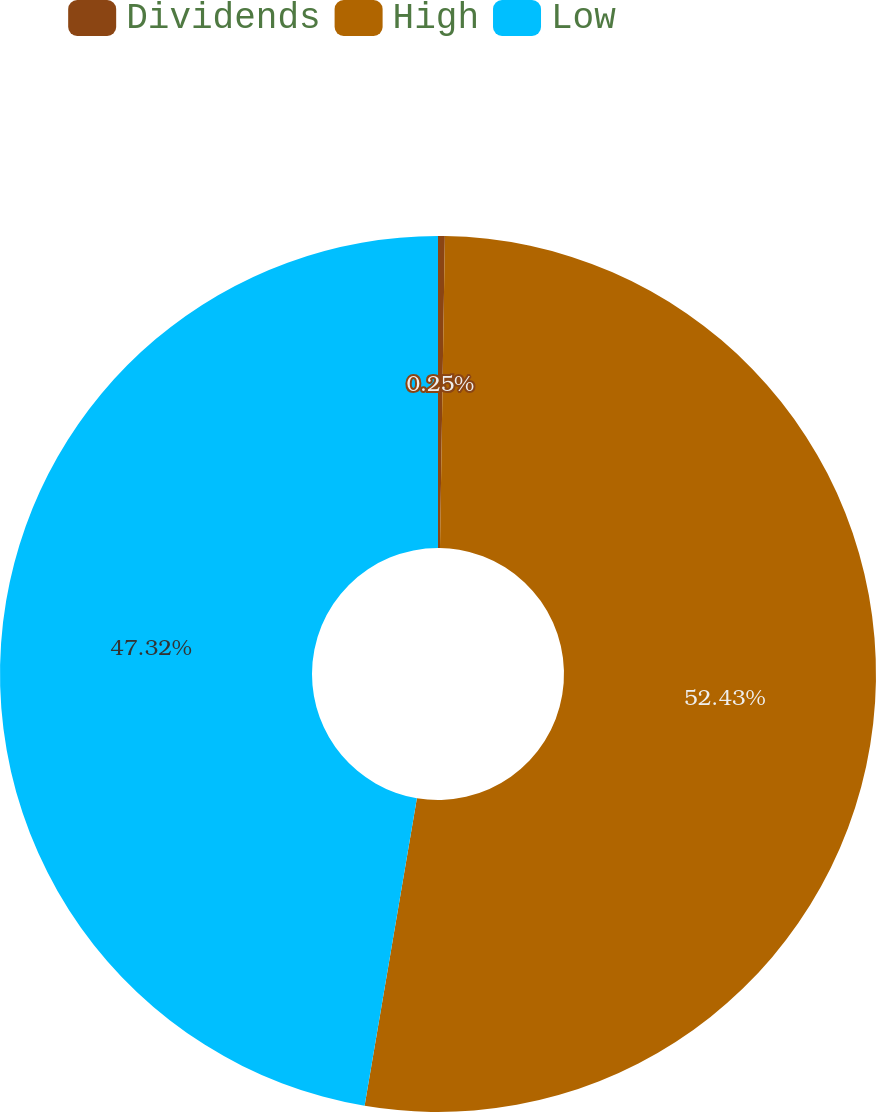Convert chart. <chart><loc_0><loc_0><loc_500><loc_500><pie_chart><fcel>Dividends<fcel>High<fcel>Low<nl><fcel>0.25%<fcel>52.43%<fcel>47.32%<nl></chart> 